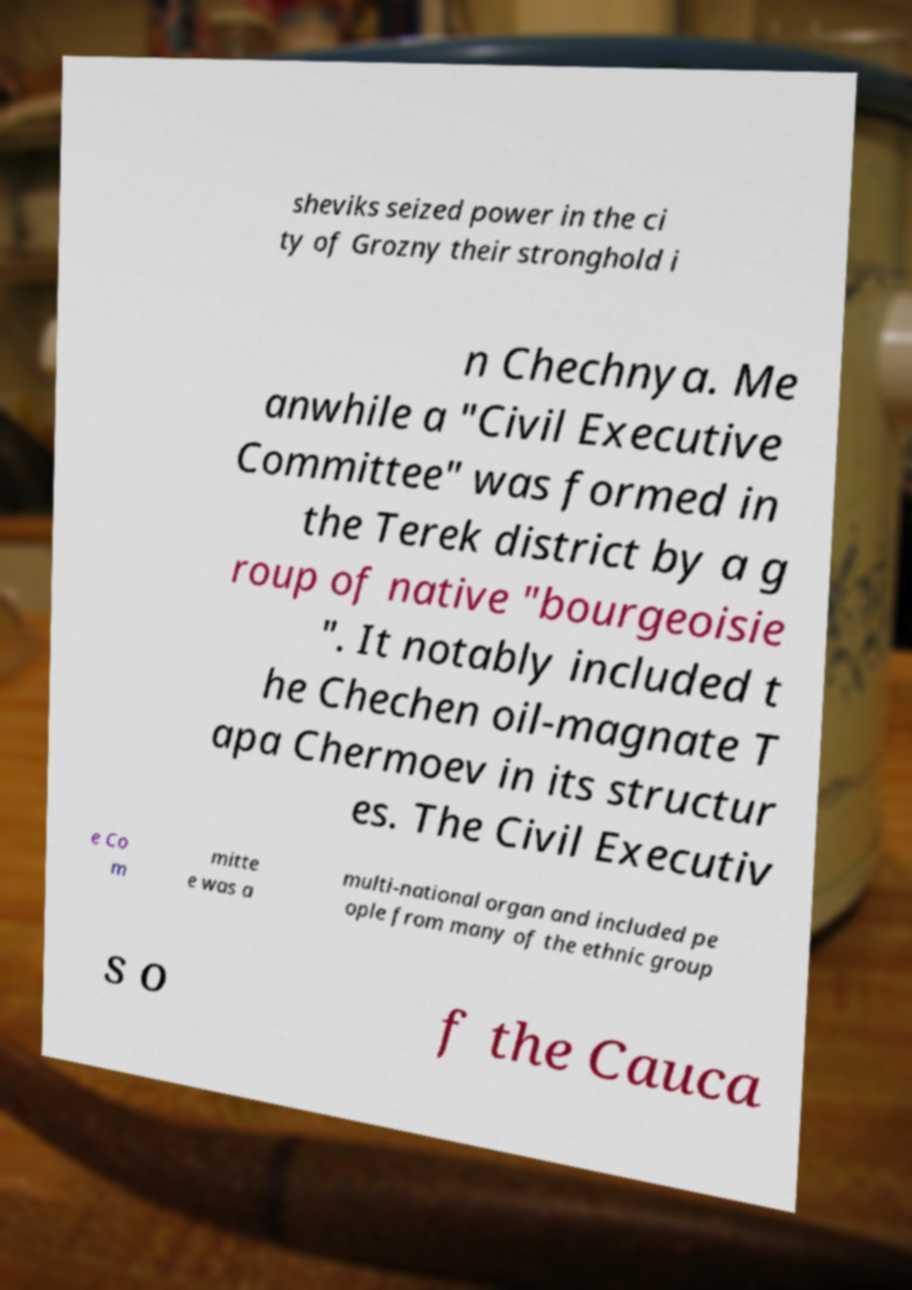Can you read and provide the text displayed in the image?This photo seems to have some interesting text. Can you extract and type it out for me? sheviks seized power in the ci ty of Grozny their stronghold i n Chechnya. Me anwhile a "Civil Executive Committee" was formed in the Terek district by a g roup of native "bourgeoisie ". It notably included t he Chechen oil-magnate T apa Chermoev in its structur es. The Civil Executiv e Co m mitte e was a multi-national organ and included pe ople from many of the ethnic group s o f the Cauca 